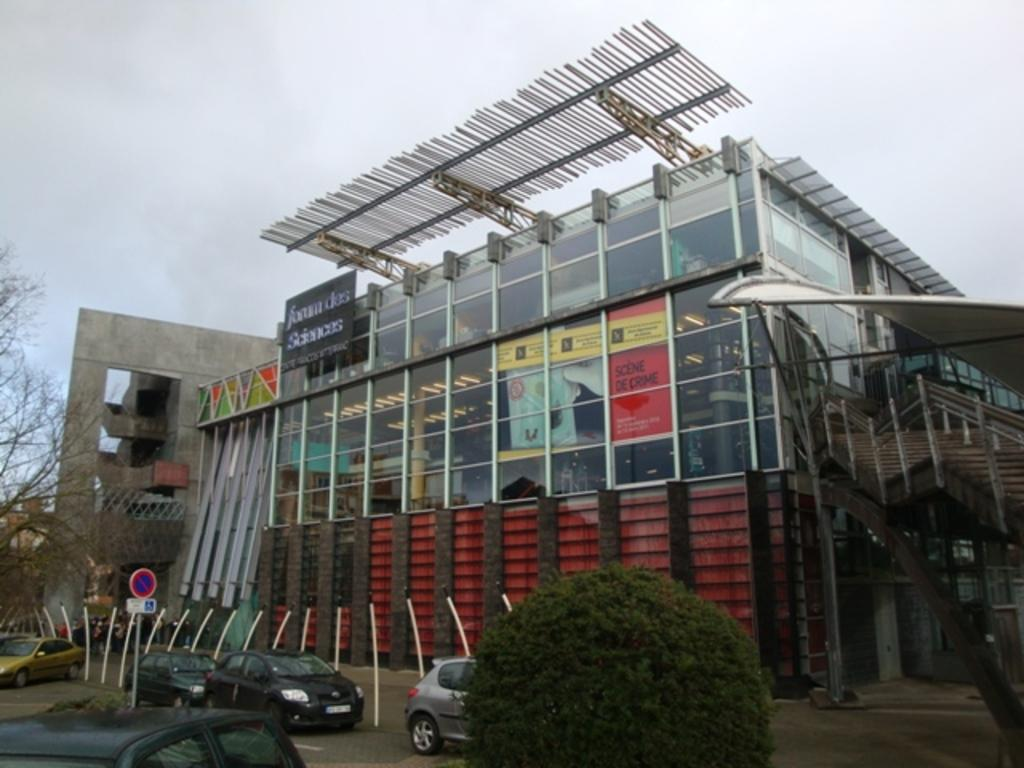What type of structures can be seen in the image? There are buildings in the image. What objects are present near the buildings? There are boards, stairs, trees, poles, and a bush in the image. What is happening on the road in the image? There are vehicles on the road in the image. What is visible at the top of the image? The sky is visible at the top of the image. Can you see a plate spinning on a spark in the image? There is no plate spinning on a spark present in the image. Is there a hen walking on the stairs in the image? There is no hen present in the image. 